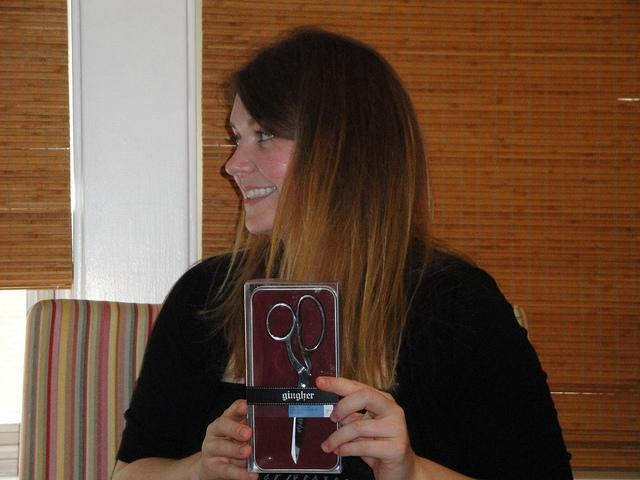What is the design of the chair? Please explain your reasoning. striped. The design of the chair is striped. 